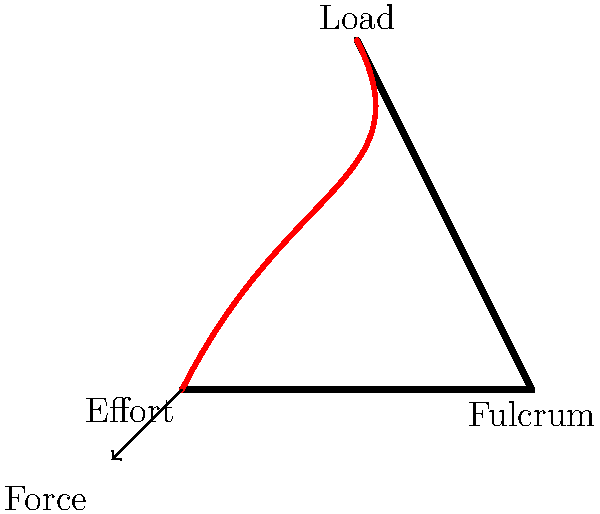In the context of product documentation for a biomechanics application, consider the illustration of a simple lever system in the human body. Which type of lever does this represent, and how does it relate to the efficiency of muscle force transmission? To answer this question, let's analyze the illustration step-by-step:

1. Identify the components:
   - The fulcrum (pivot point) is at the elbow joint (point B).
   - The load (resistance) is at the hand (point C).
   - The effort (muscle force) is applied at the forearm (point A).

2. Determine the lever type:
   - In this system, the fulcrum is between the effort and the load.
   - This arrangement corresponds to a Class III lever.

3. Understand the efficiency of force transmission:
   - In a Class III lever, the effort arm (distance from fulcrum to effort) is shorter than the load arm (distance from fulcrum to load).
   - This means that the force applied by the muscle must be greater than the load being lifted.
   - The mechanical advantage is less than 1, indicating that force is sacrificed for speed and range of motion.

4. Relate to product documentation:
   - In documenting this for a biomechanics application, it's crucial to highlight that while this system may seem inefficient in terms of force, it actually provides:
     a) Greater speed of movement
     b) Larger range of motion
   - These factors are essential for many human movements, such as lifting objects or performing quick actions.

5. Customer satisfaction perspective:
   - Clear documentation of this concept helps users understand the trade-offs in human biomechanics.
   - It can lead to better design of exercise equipment, rehabilitation devices, or ergonomic tools.
   - Properly explaining this concept can enhance user comprehension and satisfaction with the product.
Answer: Class III lever; sacrifices force for speed and range of motion. 